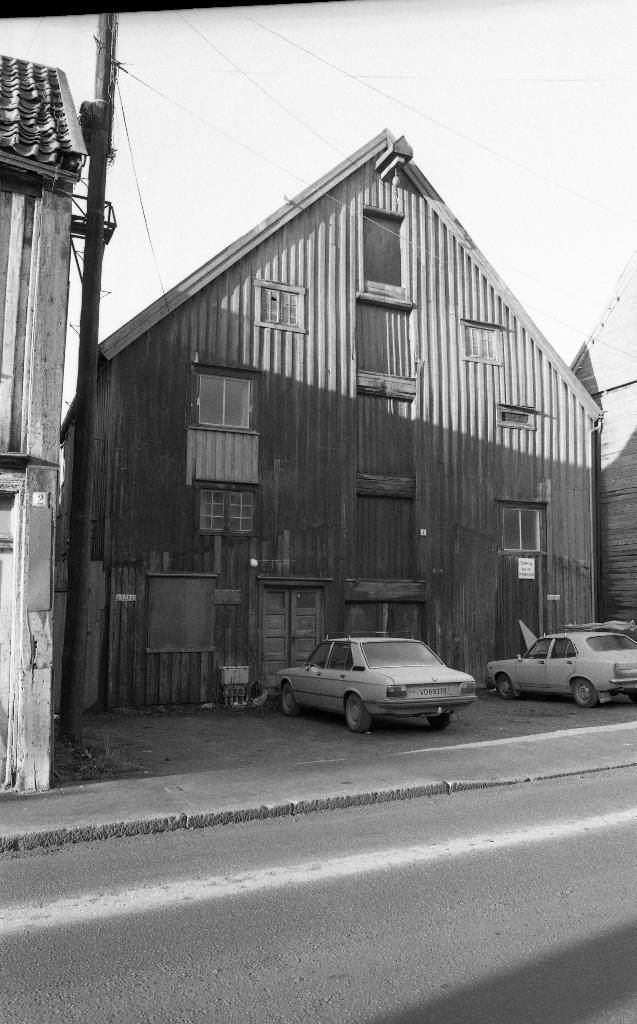What is the color scheme of the image? The image is black and white. What can be seen running through the image? There is a road in the image. What is located beside the road? There is a pavement beside the road. What type of vehicles are on the pavement? There are cars on the pavement. What type of buildings can be seen in the image? There are houses in the image. What other object can be seen in the image? There is a pole in the image. How many tigers can be seen walking on the road in the image? There are no tigers present in the image; it only features a road, pavement, cars, houses, and a pole. What type of trucks are parked on the pavement in the image? There are no trucks present in the image; it only features cars parked on the pavement. 